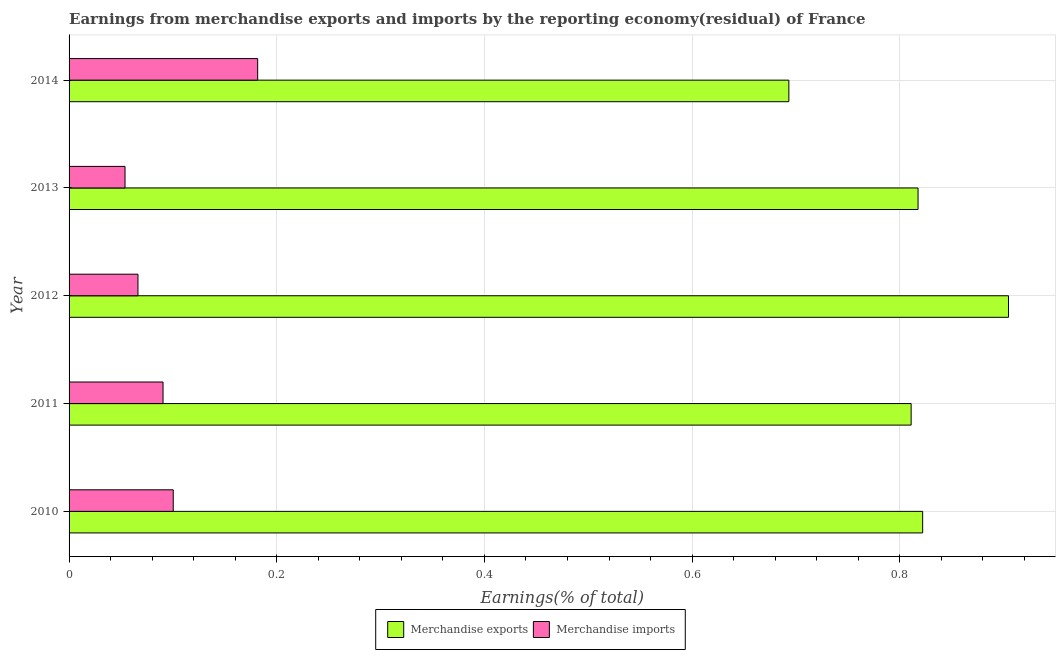How many bars are there on the 4th tick from the top?
Make the answer very short. 2. In how many cases, is the number of bars for a given year not equal to the number of legend labels?
Ensure brevity in your answer.  0. What is the earnings from merchandise imports in 2010?
Your answer should be very brief. 0.1. Across all years, what is the maximum earnings from merchandise exports?
Provide a short and direct response. 0.9. Across all years, what is the minimum earnings from merchandise exports?
Your answer should be very brief. 0.69. In which year was the earnings from merchandise imports maximum?
Keep it short and to the point. 2014. In which year was the earnings from merchandise exports minimum?
Ensure brevity in your answer.  2014. What is the total earnings from merchandise exports in the graph?
Give a very brief answer. 4.05. What is the difference between the earnings from merchandise exports in 2011 and that in 2012?
Your answer should be very brief. -0.09. What is the difference between the earnings from merchandise exports in 2010 and the earnings from merchandise imports in 2014?
Your response must be concise. 0.64. What is the average earnings from merchandise exports per year?
Ensure brevity in your answer.  0.81. In the year 2010, what is the difference between the earnings from merchandise imports and earnings from merchandise exports?
Keep it short and to the point. -0.72. What is the difference between the highest and the second highest earnings from merchandise exports?
Your answer should be compact. 0.08. What is the difference between the highest and the lowest earnings from merchandise imports?
Provide a succinct answer. 0.13. In how many years, is the earnings from merchandise exports greater than the average earnings from merchandise exports taken over all years?
Offer a terse response. 4. Is the sum of the earnings from merchandise imports in 2010 and 2014 greater than the maximum earnings from merchandise exports across all years?
Your response must be concise. No. What does the 1st bar from the top in 2013 represents?
Offer a very short reply. Merchandise imports. What does the 1st bar from the bottom in 2011 represents?
Give a very brief answer. Merchandise exports. Are all the bars in the graph horizontal?
Ensure brevity in your answer.  Yes. How many years are there in the graph?
Your response must be concise. 5. Does the graph contain any zero values?
Your response must be concise. No. What is the title of the graph?
Make the answer very short. Earnings from merchandise exports and imports by the reporting economy(residual) of France. Does "Research and Development" appear as one of the legend labels in the graph?
Provide a succinct answer. No. What is the label or title of the X-axis?
Make the answer very short. Earnings(% of total). What is the Earnings(% of total) in Merchandise exports in 2010?
Ensure brevity in your answer.  0.82. What is the Earnings(% of total) in Merchandise imports in 2010?
Your answer should be very brief. 0.1. What is the Earnings(% of total) of Merchandise exports in 2011?
Give a very brief answer. 0.81. What is the Earnings(% of total) in Merchandise imports in 2011?
Offer a terse response. 0.09. What is the Earnings(% of total) in Merchandise exports in 2012?
Offer a very short reply. 0.9. What is the Earnings(% of total) of Merchandise imports in 2012?
Provide a succinct answer. 0.07. What is the Earnings(% of total) in Merchandise exports in 2013?
Give a very brief answer. 0.82. What is the Earnings(% of total) in Merchandise imports in 2013?
Give a very brief answer. 0.05. What is the Earnings(% of total) of Merchandise exports in 2014?
Give a very brief answer. 0.69. What is the Earnings(% of total) of Merchandise imports in 2014?
Provide a succinct answer. 0.18. Across all years, what is the maximum Earnings(% of total) in Merchandise exports?
Offer a terse response. 0.9. Across all years, what is the maximum Earnings(% of total) of Merchandise imports?
Provide a short and direct response. 0.18. Across all years, what is the minimum Earnings(% of total) in Merchandise exports?
Ensure brevity in your answer.  0.69. Across all years, what is the minimum Earnings(% of total) in Merchandise imports?
Offer a very short reply. 0.05. What is the total Earnings(% of total) in Merchandise exports in the graph?
Offer a terse response. 4.05. What is the total Earnings(% of total) in Merchandise imports in the graph?
Ensure brevity in your answer.  0.49. What is the difference between the Earnings(% of total) in Merchandise exports in 2010 and that in 2011?
Offer a terse response. 0.01. What is the difference between the Earnings(% of total) of Merchandise imports in 2010 and that in 2011?
Provide a short and direct response. 0.01. What is the difference between the Earnings(% of total) of Merchandise exports in 2010 and that in 2012?
Ensure brevity in your answer.  -0.08. What is the difference between the Earnings(% of total) in Merchandise imports in 2010 and that in 2012?
Ensure brevity in your answer.  0.03. What is the difference between the Earnings(% of total) of Merchandise exports in 2010 and that in 2013?
Give a very brief answer. 0. What is the difference between the Earnings(% of total) of Merchandise imports in 2010 and that in 2013?
Ensure brevity in your answer.  0.05. What is the difference between the Earnings(% of total) of Merchandise exports in 2010 and that in 2014?
Your answer should be compact. 0.13. What is the difference between the Earnings(% of total) of Merchandise imports in 2010 and that in 2014?
Offer a very short reply. -0.08. What is the difference between the Earnings(% of total) of Merchandise exports in 2011 and that in 2012?
Your answer should be compact. -0.09. What is the difference between the Earnings(% of total) of Merchandise imports in 2011 and that in 2012?
Provide a short and direct response. 0.02. What is the difference between the Earnings(% of total) in Merchandise exports in 2011 and that in 2013?
Ensure brevity in your answer.  -0.01. What is the difference between the Earnings(% of total) of Merchandise imports in 2011 and that in 2013?
Provide a succinct answer. 0.04. What is the difference between the Earnings(% of total) of Merchandise exports in 2011 and that in 2014?
Offer a terse response. 0.12. What is the difference between the Earnings(% of total) in Merchandise imports in 2011 and that in 2014?
Your answer should be very brief. -0.09. What is the difference between the Earnings(% of total) of Merchandise exports in 2012 and that in 2013?
Your answer should be compact. 0.09. What is the difference between the Earnings(% of total) in Merchandise imports in 2012 and that in 2013?
Ensure brevity in your answer.  0.01. What is the difference between the Earnings(% of total) in Merchandise exports in 2012 and that in 2014?
Make the answer very short. 0.21. What is the difference between the Earnings(% of total) in Merchandise imports in 2012 and that in 2014?
Offer a very short reply. -0.12. What is the difference between the Earnings(% of total) of Merchandise exports in 2013 and that in 2014?
Ensure brevity in your answer.  0.12. What is the difference between the Earnings(% of total) in Merchandise imports in 2013 and that in 2014?
Your answer should be very brief. -0.13. What is the difference between the Earnings(% of total) in Merchandise exports in 2010 and the Earnings(% of total) in Merchandise imports in 2011?
Keep it short and to the point. 0.73. What is the difference between the Earnings(% of total) of Merchandise exports in 2010 and the Earnings(% of total) of Merchandise imports in 2012?
Keep it short and to the point. 0.76. What is the difference between the Earnings(% of total) in Merchandise exports in 2010 and the Earnings(% of total) in Merchandise imports in 2013?
Make the answer very short. 0.77. What is the difference between the Earnings(% of total) in Merchandise exports in 2010 and the Earnings(% of total) in Merchandise imports in 2014?
Keep it short and to the point. 0.64. What is the difference between the Earnings(% of total) in Merchandise exports in 2011 and the Earnings(% of total) in Merchandise imports in 2012?
Make the answer very short. 0.74. What is the difference between the Earnings(% of total) in Merchandise exports in 2011 and the Earnings(% of total) in Merchandise imports in 2013?
Your answer should be compact. 0.76. What is the difference between the Earnings(% of total) of Merchandise exports in 2011 and the Earnings(% of total) of Merchandise imports in 2014?
Your answer should be very brief. 0.63. What is the difference between the Earnings(% of total) in Merchandise exports in 2012 and the Earnings(% of total) in Merchandise imports in 2013?
Your response must be concise. 0.85. What is the difference between the Earnings(% of total) of Merchandise exports in 2012 and the Earnings(% of total) of Merchandise imports in 2014?
Give a very brief answer. 0.72. What is the difference between the Earnings(% of total) of Merchandise exports in 2013 and the Earnings(% of total) of Merchandise imports in 2014?
Provide a short and direct response. 0.64. What is the average Earnings(% of total) of Merchandise exports per year?
Give a very brief answer. 0.81. What is the average Earnings(% of total) in Merchandise imports per year?
Provide a succinct answer. 0.1. In the year 2010, what is the difference between the Earnings(% of total) of Merchandise exports and Earnings(% of total) of Merchandise imports?
Make the answer very short. 0.72. In the year 2011, what is the difference between the Earnings(% of total) in Merchandise exports and Earnings(% of total) in Merchandise imports?
Your answer should be compact. 0.72. In the year 2012, what is the difference between the Earnings(% of total) in Merchandise exports and Earnings(% of total) in Merchandise imports?
Keep it short and to the point. 0.84. In the year 2013, what is the difference between the Earnings(% of total) in Merchandise exports and Earnings(% of total) in Merchandise imports?
Your answer should be very brief. 0.76. In the year 2014, what is the difference between the Earnings(% of total) in Merchandise exports and Earnings(% of total) in Merchandise imports?
Make the answer very short. 0.51. What is the ratio of the Earnings(% of total) of Merchandise exports in 2010 to that in 2011?
Your response must be concise. 1.01. What is the ratio of the Earnings(% of total) in Merchandise imports in 2010 to that in 2011?
Offer a terse response. 1.11. What is the ratio of the Earnings(% of total) of Merchandise exports in 2010 to that in 2012?
Provide a succinct answer. 0.91. What is the ratio of the Earnings(% of total) in Merchandise imports in 2010 to that in 2012?
Offer a terse response. 1.51. What is the ratio of the Earnings(% of total) of Merchandise exports in 2010 to that in 2013?
Give a very brief answer. 1.01. What is the ratio of the Earnings(% of total) of Merchandise imports in 2010 to that in 2013?
Make the answer very short. 1.86. What is the ratio of the Earnings(% of total) in Merchandise exports in 2010 to that in 2014?
Ensure brevity in your answer.  1.19. What is the ratio of the Earnings(% of total) in Merchandise imports in 2010 to that in 2014?
Keep it short and to the point. 0.55. What is the ratio of the Earnings(% of total) of Merchandise exports in 2011 to that in 2012?
Offer a terse response. 0.9. What is the ratio of the Earnings(% of total) of Merchandise imports in 2011 to that in 2012?
Provide a short and direct response. 1.36. What is the ratio of the Earnings(% of total) in Merchandise exports in 2011 to that in 2013?
Make the answer very short. 0.99. What is the ratio of the Earnings(% of total) of Merchandise imports in 2011 to that in 2013?
Offer a very short reply. 1.68. What is the ratio of the Earnings(% of total) of Merchandise exports in 2011 to that in 2014?
Make the answer very short. 1.17. What is the ratio of the Earnings(% of total) of Merchandise imports in 2011 to that in 2014?
Your answer should be very brief. 0.5. What is the ratio of the Earnings(% of total) in Merchandise exports in 2012 to that in 2013?
Offer a terse response. 1.11. What is the ratio of the Earnings(% of total) in Merchandise imports in 2012 to that in 2013?
Give a very brief answer. 1.23. What is the ratio of the Earnings(% of total) of Merchandise exports in 2012 to that in 2014?
Ensure brevity in your answer.  1.31. What is the ratio of the Earnings(% of total) of Merchandise imports in 2012 to that in 2014?
Your answer should be very brief. 0.37. What is the ratio of the Earnings(% of total) in Merchandise exports in 2013 to that in 2014?
Offer a very short reply. 1.18. What is the ratio of the Earnings(% of total) of Merchandise imports in 2013 to that in 2014?
Your answer should be very brief. 0.3. What is the difference between the highest and the second highest Earnings(% of total) in Merchandise exports?
Provide a succinct answer. 0.08. What is the difference between the highest and the second highest Earnings(% of total) of Merchandise imports?
Offer a very short reply. 0.08. What is the difference between the highest and the lowest Earnings(% of total) of Merchandise exports?
Your answer should be very brief. 0.21. What is the difference between the highest and the lowest Earnings(% of total) in Merchandise imports?
Give a very brief answer. 0.13. 